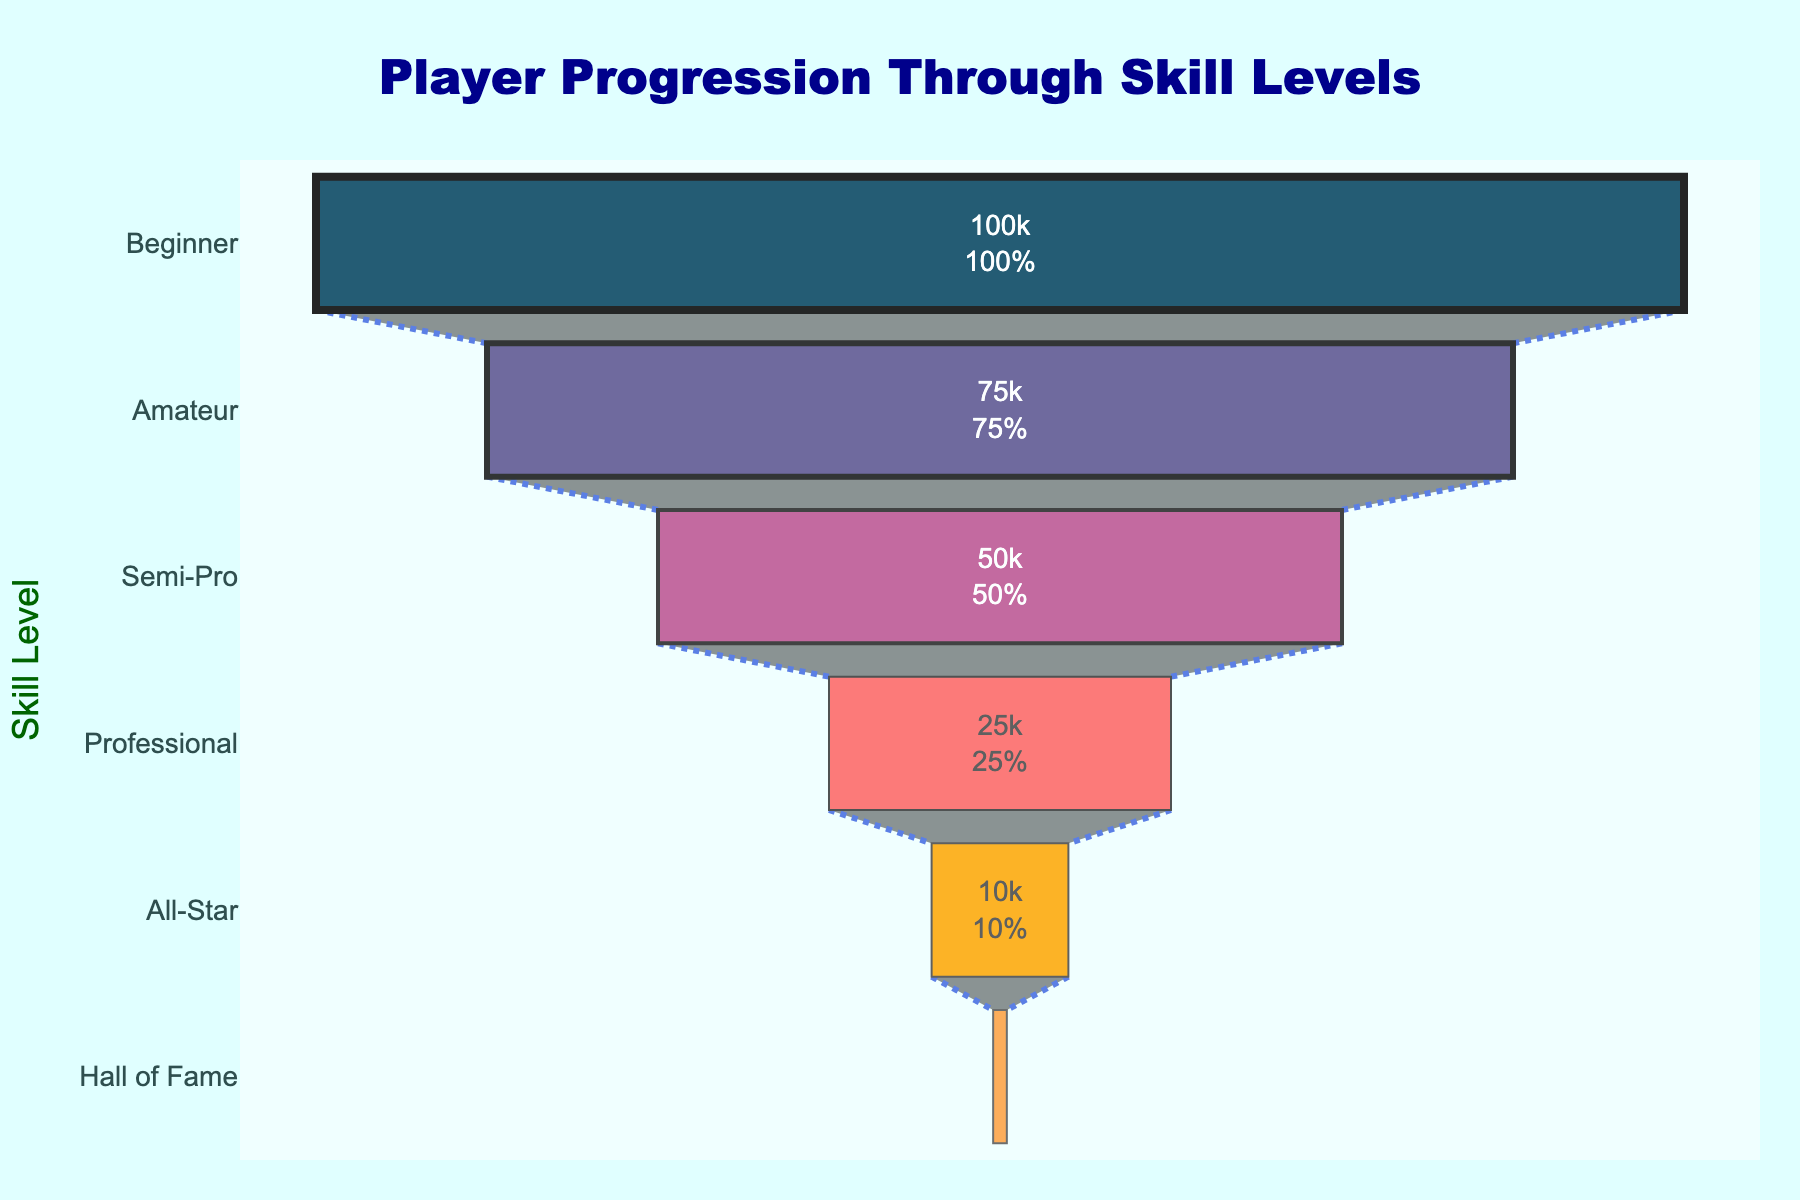What is the title of the figure? The title is located at the top center of the figure and is prominently displayed. It reads "Player Progression Through Skill Levels".
Answer: Player Progression Through Skill Levels How many stages of player progression are shown in the figure? The figure lists each stage on the y-axis. By counting them, we see stages from "Beginner" to "Hall of Fame".
Answer: Six stages What percentage of players reach the "Professional" stage starting from "Beginner"? The text information inside the sections displays this percentage. From "Beginner" to "Professional", the funnel shows the cumulative percentage decrease.
Answer: 25% How many more players are in the "Amateur" stage compared to the "All-Star" stage? By referring to the number of players listed inside each section: "Amateur" (75,000) and "All-Star" (10,000), the difference is calculated as 75,000 - 10,000.
Answer: 65,000 Which stage loses the most players? By observing the differences in player counts in each consecutive stage, "Amateur" loses the most players compared to "Beginner" (100,000 - 75,000).
Answer: Beginner to Amateur What is the average number of players across all stages? Sum up the number of players across all stages: 100,000 + 75,000 + 50,000 + 25,000 + 10,000 + 1,000 = 261,000. Divide this by the number of stages (6).
Answer: 43,500 What color represents the "Semi-Pro" stage in the funnel chart? Each stage has a distinct color. The "Semi-Pro" stage is the third stage from the top, colored in #bc5090.
Answer: #bc5090 Which stage has the highest attrition rate? Compute the attrition rate by comparing consecutive stages' player counts. "Beginner" to "Amateur" has the highest (100,000 - 75,000) / 100,000 = 25%. Hyper-decreasing stages should be investigated comparably.
Answer: Beginner to Amateur How does the total number of players progress from "Professional" to "Hall of Fame"? By observing player numbers, from "Professional" (25,000), "All-Star" (10,000), to "Hall of Fame" (1,000), there is a sequential reduction.
Answer: 25,000 → 10,000 → 1,000 What proportion of players makes it to the "Hall of Fame" starting from "Professional"? Calculate the ratio of "Hall of Fame" (1,000) to "Professional" (25,000). 1,000 / 25,000 = 0.04 or 4%.
Answer: 4% 